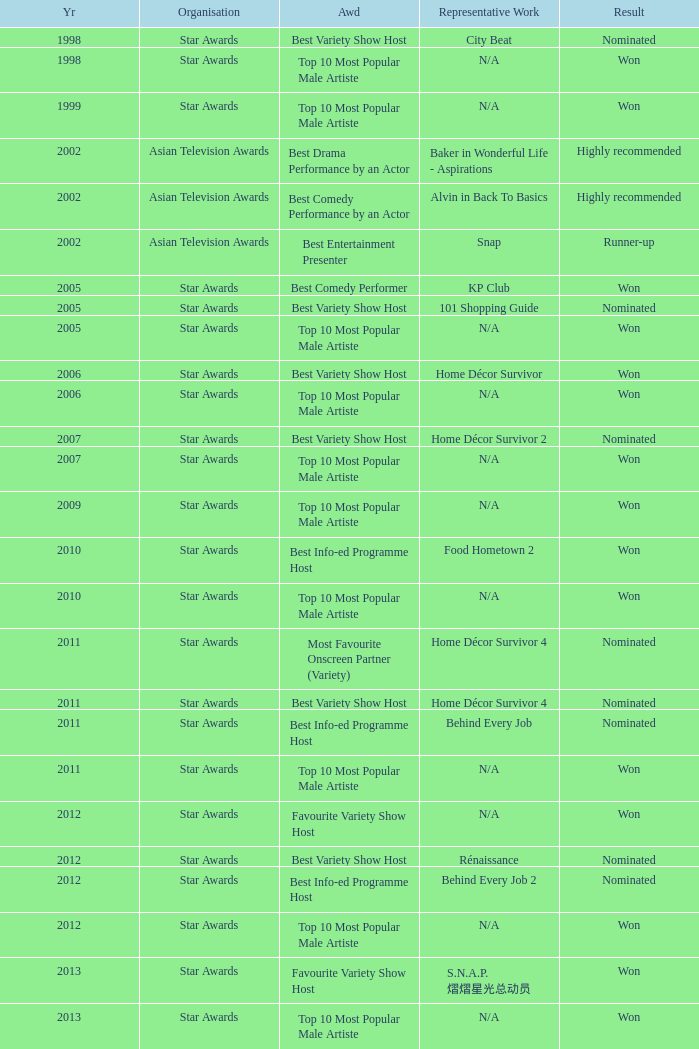What is the award for the Star Awards earlier than 2005 and the result is won? Top 10 Most Popular Male Artiste, Top 10 Most Popular Male Artiste. 